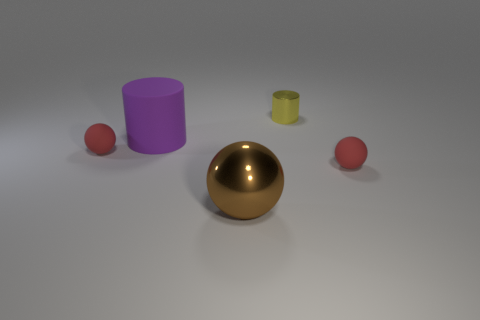Subtract all red balls. How many were subtracted if there are1red balls left? 1 Subtract all brown metal balls. How many balls are left? 2 Subtract all red spheres. How many spheres are left? 1 Subtract all spheres. How many objects are left? 2 Subtract 3 balls. How many balls are left? 0 Subtract all green cylinders. Subtract all purple balls. How many cylinders are left? 2 Subtract all red cubes. How many purple cylinders are left? 1 Subtract all yellow rubber cylinders. Subtract all large rubber objects. How many objects are left? 4 Add 5 rubber spheres. How many rubber spheres are left? 7 Add 3 large rubber objects. How many large rubber objects exist? 4 